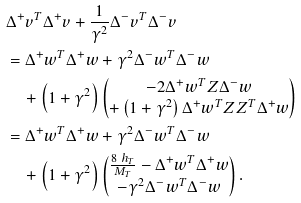Convert formula to latex. <formula><loc_0><loc_0><loc_500><loc_500>& \Delta ^ { + } v ^ { T } \Delta ^ { + } v + \frac { 1 } { \gamma ^ { 2 } } \Delta ^ { - } v ^ { T } \Delta ^ { - } v \\ & = \Delta ^ { + } w ^ { T } \Delta ^ { + } w + \gamma ^ { 2 } \Delta ^ { - } w ^ { T } \Delta ^ { - } w \\ & \quad + \left ( 1 + \gamma ^ { 2 } \right ) \begin{pmatrix} - 2 \Delta ^ { + } w ^ { T } Z \Delta ^ { - } w \\ + \left ( 1 + \gamma ^ { 2 } \right ) \Delta ^ { + } w ^ { T } Z Z ^ { T } \Delta ^ { + } w \end{pmatrix} \\ & = \Delta ^ { + } w ^ { T } \Delta ^ { + } w + \gamma ^ { 2 } \Delta ^ { - } w ^ { T } \Delta ^ { - } w \\ & \quad + \left ( 1 + \gamma ^ { 2 } \right ) \begin{pmatrix} \frac { 8 \ h _ { T } } { M _ { T } } - \Delta ^ { + } w ^ { T } \Delta ^ { + } w \\ - \gamma ^ { 2 } \Delta ^ { - } w ^ { T } \Delta ^ { - } w \end{pmatrix} .</formula> 